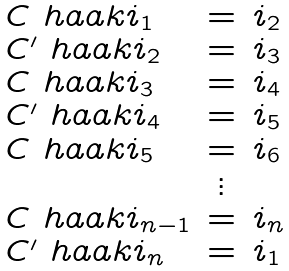<formula> <loc_0><loc_0><loc_500><loc_500>\begin{array} { l c l } C \ h a a k { i _ { 1 } } & = & i _ { 2 } \\ C ^ { \prime } \ h a a k { i _ { 2 } } & = & i _ { 3 } \\ C \ h a a k { i _ { 3 } } & = & i _ { 4 } \\ C ^ { \prime } \ h a a k { i _ { 4 } } & = & i _ { 5 } \\ C \ h a a k { i _ { 5 } } & = & i _ { 6 } \\ & \vdots & \\ C \ h a a k { i _ { n - 1 } } & = & i _ { n } \\ C ^ { \prime } \ h a a k { i _ { n } } & = & i _ { 1 } \\ \end{array}</formula> 